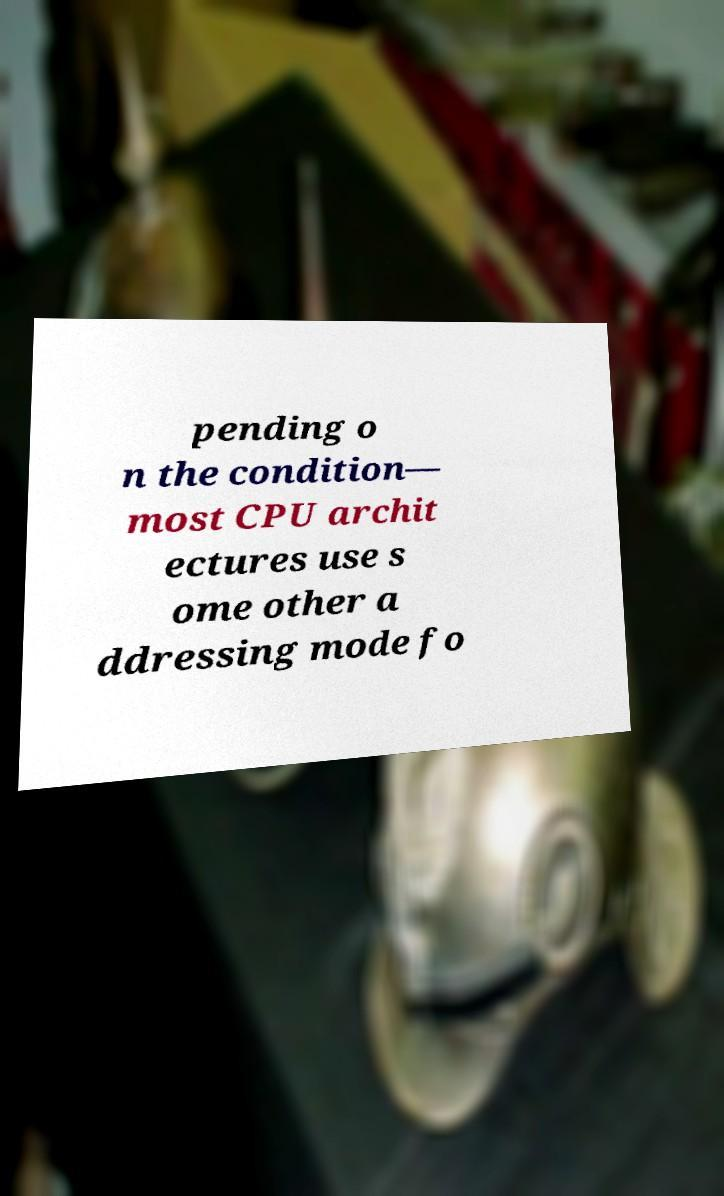Could you extract and type out the text from this image? pending o n the condition— most CPU archit ectures use s ome other a ddressing mode fo 